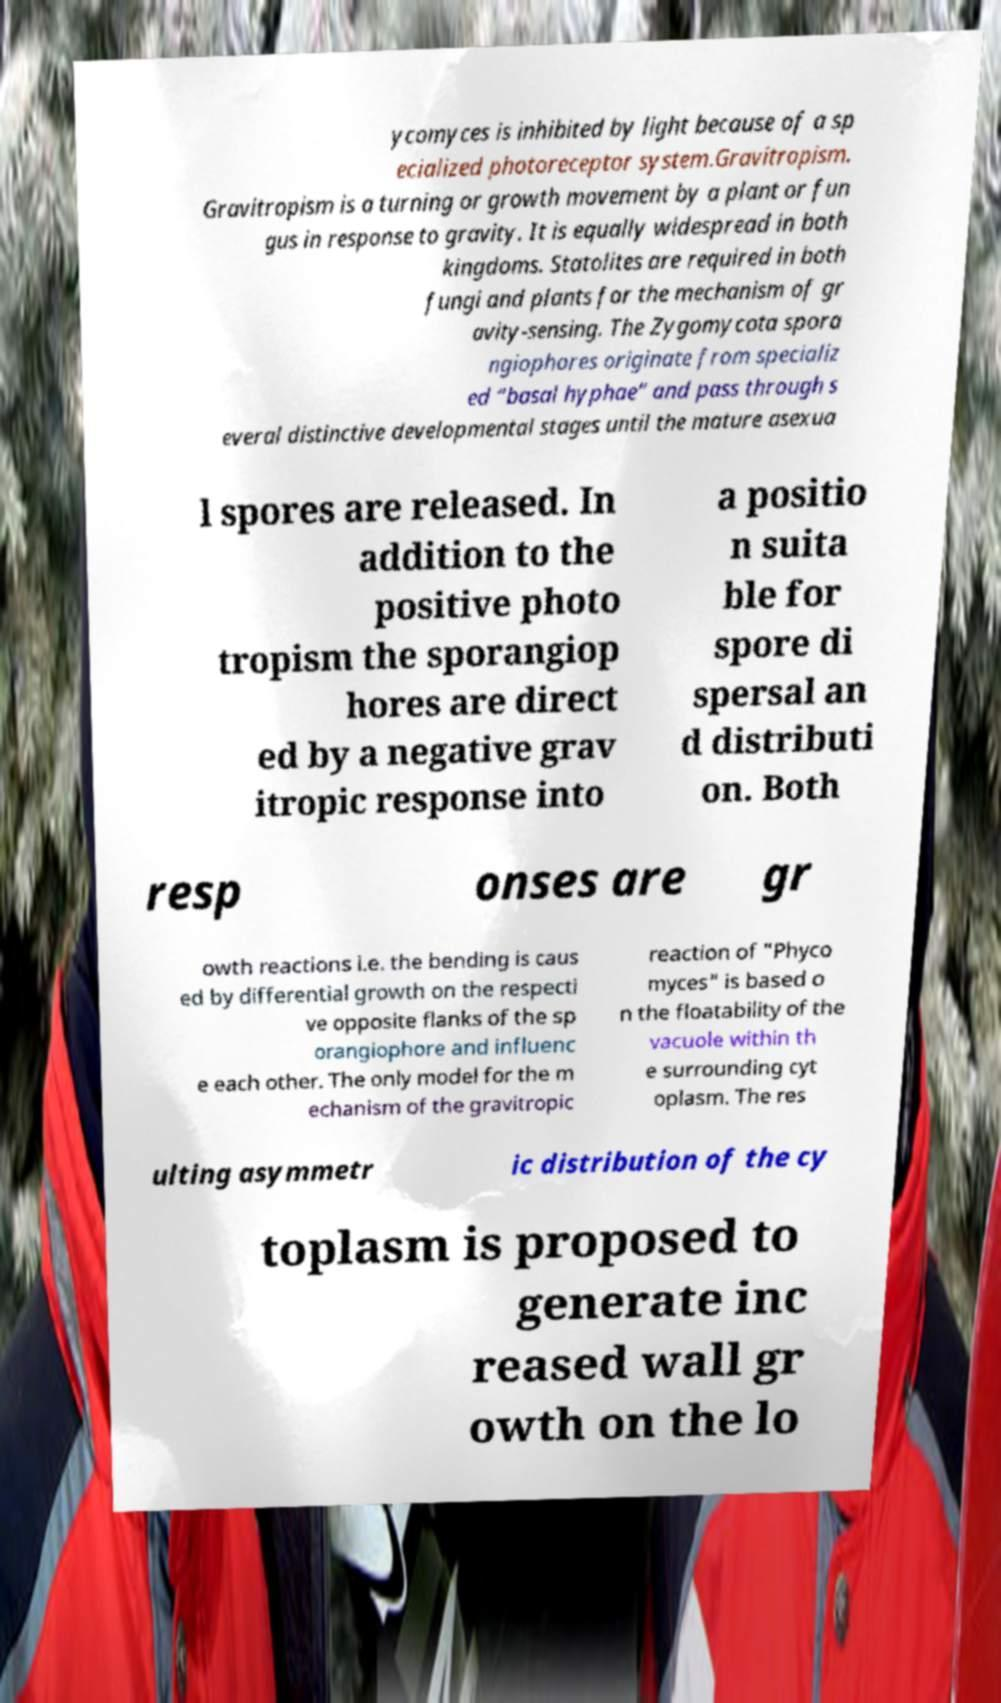There's text embedded in this image that I need extracted. Can you transcribe it verbatim? ycomyces is inhibited by light because of a sp ecialized photoreceptor system.Gravitropism. Gravitropism is a turning or growth movement by a plant or fun gus in response to gravity. It is equally widespread in both kingdoms. Statolites are required in both fungi and plants for the mechanism of gr avity-sensing. The Zygomycota spora ngiophores originate from specializ ed “basal hyphae” and pass through s everal distinctive developmental stages until the mature asexua l spores are released. In addition to the positive photo tropism the sporangiop hores are direct ed by a negative grav itropic response into a positio n suita ble for spore di spersal an d distributi on. Both resp onses are gr owth reactions i.e. the bending is caus ed by differential growth on the respecti ve opposite flanks of the sp orangiophore and influenc e each other. The only model for the m echanism of the gravitropic reaction of "Phyco myces" is based o n the floatability of the vacuole within th e surrounding cyt oplasm. The res ulting asymmetr ic distribution of the cy toplasm is proposed to generate inc reased wall gr owth on the lo 